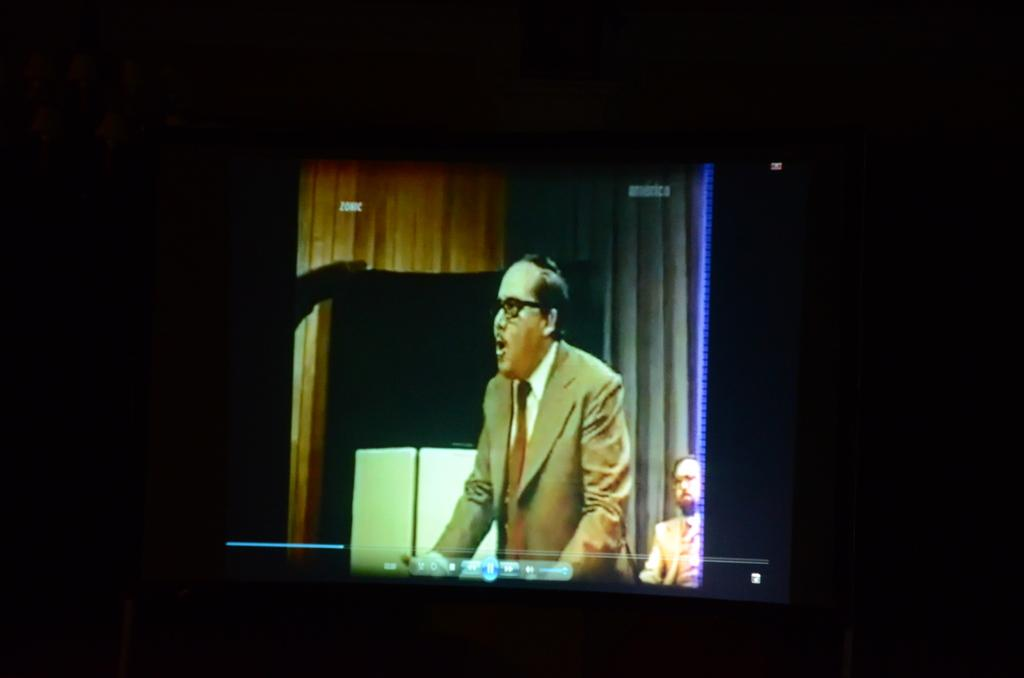What is the main object in the image? There is a screen in the image. Can you describe the people in the image? A person is standing in the image, and there is another person on the right side of the image. What can be inferred about the lighting in the image? The background of the image is dark. What type of corn is being measured by the person on the right side of the image? There is no corn or measuring activity present in the image. What type of vegetable is being prepared by the person standing in the image? There is no vegetable preparation or any vegetables visible in the image. 